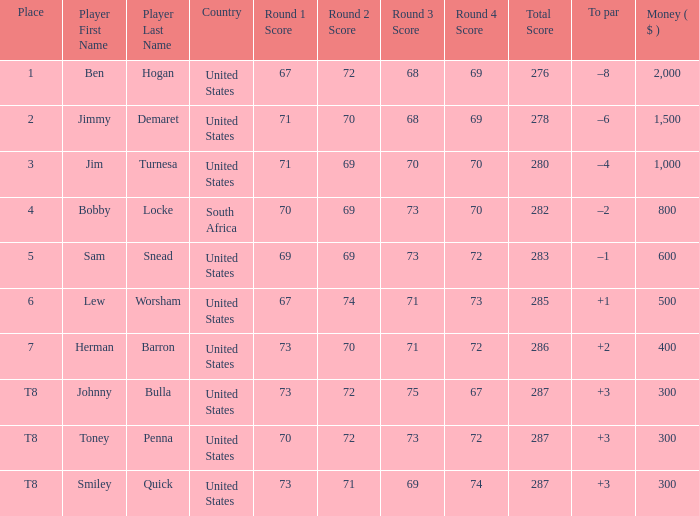What is the Place of the Player with Money greater than 300 and a Score of 71-69-70-70=280? 3.0. 